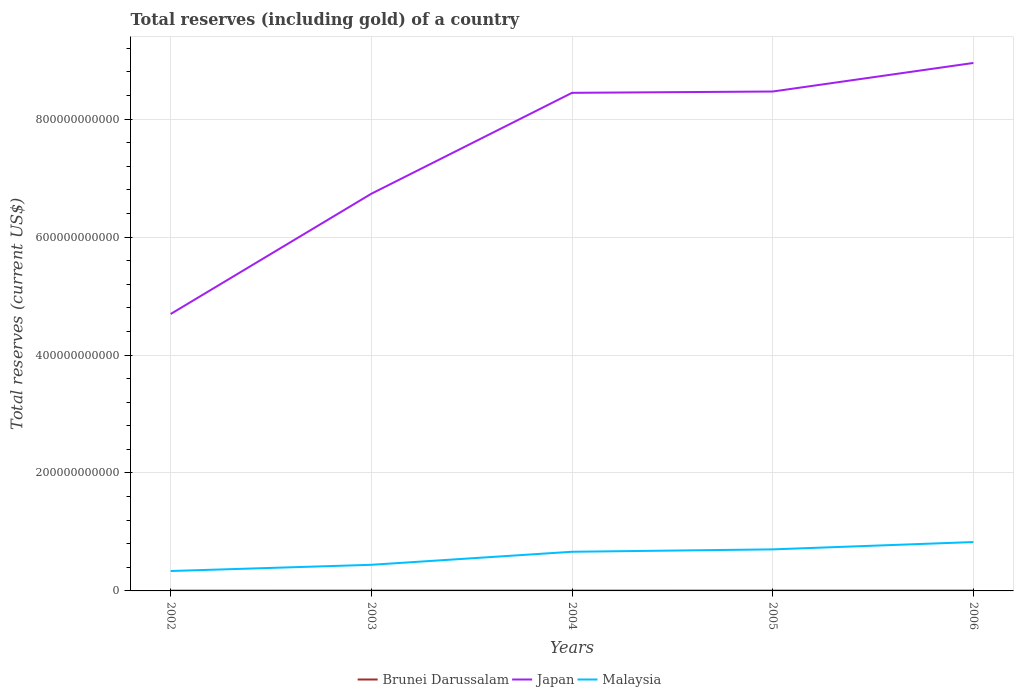Does the line corresponding to Japan intersect with the line corresponding to Brunei Darussalam?
Give a very brief answer. No. Is the number of lines equal to the number of legend labels?
Your answer should be very brief. Yes. Across all years, what is the maximum total reserves (including gold) in Brunei Darussalam?
Your answer should be compact. 4.49e+08. In which year was the total reserves (including gold) in Japan maximum?
Offer a terse response. 2002. What is the total total reserves (including gold) in Brunei Darussalam in the graph?
Provide a succinct answer. -4.29e+07. What is the difference between the highest and the second highest total reserves (including gold) in Brunei Darussalam?
Provide a succinct answer. 6.46e+07. How many years are there in the graph?
Your answer should be very brief. 5. What is the difference between two consecutive major ticks on the Y-axis?
Provide a succinct answer. 2.00e+11. Does the graph contain grids?
Your response must be concise. Yes. Where does the legend appear in the graph?
Make the answer very short. Bottom center. How many legend labels are there?
Provide a succinct answer. 3. How are the legend labels stacked?
Offer a very short reply. Horizontal. What is the title of the graph?
Your response must be concise. Total reserves (including gold) of a country. What is the label or title of the Y-axis?
Provide a short and direct response. Total reserves (current US$). What is the Total reserves (current US$) in Brunei Darussalam in 2002?
Your response must be concise. 4.49e+08. What is the Total reserves (current US$) of Japan in 2002?
Provide a short and direct response. 4.70e+11. What is the Total reserves (current US$) of Malaysia in 2002?
Provide a short and direct response. 3.38e+1. What is the Total reserves (current US$) of Brunei Darussalam in 2003?
Make the answer very short. 4.75e+08. What is the Total reserves (current US$) in Japan in 2003?
Give a very brief answer. 6.74e+11. What is the Total reserves (current US$) in Malaysia in 2003?
Provide a short and direct response. 4.43e+1. What is the Total reserves (current US$) of Brunei Darussalam in 2004?
Ensure brevity in your answer.  4.89e+08. What is the Total reserves (current US$) of Japan in 2004?
Your response must be concise. 8.45e+11. What is the Total reserves (current US$) in Malaysia in 2004?
Offer a very short reply. 6.64e+1. What is the Total reserves (current US$) of Brunei Darussalam in 2005?
Offer a terse response. 4.92e+08. What is the Total reserves (current US$) of Japan in 2005?
Provide a short and direct response. 8.47e+11. What is the Total reserves (current US$) in Malaysia in 2005?
Give a very brief answer. 7.05e+1. What is the Total reserves (current US$) of Brunei Darussalam in 2006?
Ensure brevity in your answer.  5.14e+08. What is the Total reserves (current US$) of Japan in 2006?
Provide a succinct answer. 8.95e+11. What is the Total reserves (current US$) in Malaysia in 2006?
Make the answer very short. 8.29e+1. Across all years, what is the maximum Total reserves (current US$) in Brunei Darussalam?
Offer a very short reply. 5.14e+08. Across all years, what is the maximum Total reserves (current US$) in Japan?
Keep it short and to the point. 8.95e+11. Across all years, what is the maximum Total reserves (current US$) in Malaysia?
Give a very brief answer. 8.29e+1. Across all years, what is the minimum Total reserves (current US$) in Brunei Darussalam?
Give a very brief answer. 4.49e+08. Across all years, what is the minimum Total reserves (current US$) of Japan?
Provide a succinct answer. 4.70e+11. Across all years, what is the minimum Total reserves (current US$) of Malaysia?
Keep it short and to the point. 3.38e+1. What is the total Total reserves (current US$) in Brunei Darussalam in the graph?
Your answer should be very brief. 2.42e+09. What is the total Total reserves (current US$) in Japan in the graph?
Your response must be concise. 3.73e+12. What is the total Total reserves (current US$) in Malaysia in the graph?
Offer a terse response. 2.98e+11. What is the difference between the Total reserves (current US$) in Brunei Darussalam in 2002 and that in 2003?
Your response must be concise. -2.57e+07. What is the difference between the Total reserves (current US$) in Japan in 2002 and that in 2003?
Your answer should be very brief. -2.04e+11. What is the difference between the Total reserves (current US$) of Malaysia in 2002 and that in 2003?
Keep it short and to the point. -1.05e+1. What is the difference between the Total reserves (current US$) in Brunei Darussalam in 2002 and that in 2004?
Offer a very short reply. -3.99e+07. What is the difference between the Total reserves (current US$) of Japan in 2002 and that in 2004?
Offer a very short reply. -3.75e+11. What is the difference between the Total reserves (current US$) in Malaysia in 2002 and that in 2004?
Your answer should be very brief. -3.26e+1. What is the difference between the Total reserves (current US$) of Brunei Darussalam in 2002 and that in 2005?
Give a very brief answer. -4.29e+07. What is the difference between the Total reserves (current US$) in Japan in 2002 and that in 2005?
Your answer should be compact. -3.77e+11. What is the difference between the Total reserves (current US$) of Malaysia in 2002 and that in 2005?
Offer a very short reply. -3.67e+1. What is the difference between the Total reserves (current US$) of Brunei Darussalam in 2002 and that in 2006?
Your answer should be very brief. -6.46e+07. What is the difference between the Total reserves (current US$) in Japan in 2002 and that in 2006?
Offer a very short reply. -4.26e+11. What is the difference between the Total reserves (current US$) of Malaysia in 2002 and that in 2006?
Offer a very short reply. -4.91e+1. What is the difference between the Total reserves (current US$) in Brunei Darussalam in 2003 and that in 2004?
Give a very brief answer. -1.41e+07. What is the difference between the Total reserves (current US$) in Japan in 2003 and that in 2004?
Make the answer very short. -1.71e+11. What is the difference between the Total reserves (current US$) in Malaysia in 2003 and that in 2004?
Make the answer very short. -2.21e+1. What is the difference between the Total reserves (current US$) of Brunei Darussalam in 2003 and that in 2005?
Provide a succinct answer. -1.71e+07. What is the difference between the Total reserves (current US$) of Japan in 2003 and that in 2005?
Keep it short and to the point. -1.73e+11. What is the difference between the Total reserves (current US$) in Malaysia in 2003 and that in 2005?
Offer a terse response. -2.61e+1. What is the difference between the Total reserves (current US$) of Brunei Darussalam in 2003 and that in 2006?
Your answer should be very brief. -3.88e+07. What is the difference between the Total reserves (current US$) in Japan in 2003 and that in 2006?
Keep it short and to the point. -2.22e+11. What is the difference between the Total reserves (current US$) in Malaysia in 2003 and that in 2006?
Your response must be concise. -3.86e+1. What is the difference between the Total reserves (current US$) of Brunei Darussalam in 2004 and that in 2005?
Your response must be concise. -3.00e+06. What is the difference between the Total reserves (current US$) in Japan in 2004 and that in 2005?
Provide a short and direct response. -2.23e+09. What is the difference between the Total reserves (current US$) of Malaysia in 2004 and that in 2005?
Provide a short and direct response. -4.06e+09. What is the difference between the Total reserves (current US$) in Brunei Darussalam in 2004 and that in 2006?
Provide a short and direct response. -2.47e+07. What is the difference between the Total reserves (current US$) in Japan in 2004 and that in 2006?
Provide a short and direct response. -5.07e+1. What is the difference between the Total reserves (current US$) in Malaysia in 2004 and that in 2006?
Give a very brief answer. -1.65e+1. What is the difference between the Total reserves (current US$) of Brunei Darussalam in 2005 and that in 2006?
Ensure brevity in your answer.  -2.17e+07. What is the difference between the Total reserves (current US$) in Japan in 2005 and that in 2006?
Offer a terse response. -4.84e+1. What is the difference between the Total reserves (current US$) of Malaysia in 2005 and that in 2006?
Keep it short and to the point. -1.24e+1. What is the difference between the Total reserves (current US$) of Brunei Darussalam in 2002 and the Total reserves (current US$) of Japan in 2003?
Provide a short and direct response. -6.73e+11. What is the difference between the Total reserves (current US$) in Brunei Darussalam in 2002 and the Total reserves (current US$) in Malaysia in 2003?
Provide a succinct answer. -4.39e+1. What is the difference between the Total reserves (current US$) in Japan in 2002 and the Total reserves (current US$) in Malaysia in 2003?
Keep it short and to the point. 4.25e+11. What is the difference between the Total reserves (current US$) of Brunei Darussalam in 2002 and the Total reserves (current US$) of Japan in 2004?
Provide a succinct answer. -8.44e+11. What is the difference between the Total reserves (current US$) in Brunei Darussalam in 2002 and the Total reserves (current US$) in Malaysia in 2004?
Provide a succinct answer. -6.59e+1. What is the difference between the Total reserves (current US$) of Japan in 2002 and the Total reserves (current US$) of Malaysia in 2004?
Provide a succinct answer. 4.03e+11. What is the difference between the Total reserves (current US$) in Brunei Darussalam in 2002 and the Total reserves (current US$) in Japan in 2005?
Your response must be concise. -8.46e+11. What is the difference between the Total reserves (current US$) in Brunei Darussalam in 2002 and the Total reserves (current US$) in Malaysia in 2005?
Provide a succinct answer. -7.00e+1. What is the difference between the Total reserves (current US$) of Japan in 2002 and the Total reserves (current US$) of Malaysia in 2005?
Make the answer very short. 3.99e+11. What is the difference between the Total reserves (current US$) of Brunei Darussalam in 2002 and the Total reserves (current US$) of Japan in 2006?
Provide a short and direct response. -8.95e+11. What is the difference between the Total reserves (current US$) of Brunei Darussalam in 2002 and the Total reserves (current US$) of Malaysia in 2006?
Make the answer very short. -8.24e+1. What is the difference between the Total reserves (current US$) in Japan in 2002 and the Total reserves (current US$) in Malaysia in 2006?
Offer a very short reply. 3.87e+11. What is the difference between the Total reserves (current US$) of Brunei Darussalam in 2003 and the Total reserves (current US$) of Japan in 2004?
Offer a terse response. -8.44e+11. What is the difference between the Total reserves (current US$) of Brunei Darussalam in 2003 and the Total reserves (current US$) of Malaysia in 2004?
Your response must be concise. -6.59e+1. What is the difference between the Total reserves (current US$) of Japan in 2003 and the Total reserves (current US$) of Malaysia in 2004?
Your answer should be compact. 6.07e+11. What is the difference between the Total reserves (current US$) in Brunei Darussalam in 2003 and the Total reserves (current US$) in Japan in 2005?
Provide a short and direct response. -8.46e+11. What is the difference between the Total reserves (current US$) of Brunei Darussalam in 2003 and the Total reserves (current US$) of Malaysia in 2005?
Give a very brief answer. -7.00e+1. What is the difference between the Total reserves (current US$) of Japan in 2003 and the Total reserves (current US$) of Malaysia in 2005?
Your answer should be very brief. 6.03e+11. What is the difference between the Total reserves (current US$) in Brunei Darussalam in 2003 and the Total reserves (current US$) in Japan in 2006?
Ensure brevity in your answer.  -8.95e+11. What is the difference between the Total reserves (current US$) of Brunei Darussalam in 2003 and the Total reserves (current US$) of Malaysia in 2006?
Your answer should be compact. -8.24e+1. What is the difference between the Total reserves (current US$) in Japan in 2003 and the Total reserves (current US$) in Malaysia in 2006?
Your answer should be compact. 5.91e+11. What is the difference between the Total reserves (current US$) of Brunei Darussalam in 2004 and the Total reserves (current US$) of Japan in 2005?
Provide a short and direct response. -8.46e+11. What is the difference between the Total reserves (current US$) in Brunei Darussalam in 2004 and the Total reserves (current US$) in Malaysia in 2005?
Ensure brevity in your answer.  -7.00e+1. What is the difference between the Total reserves (current US$) of Japan in 2004 and the Total reserves (current US$) of Malaysia in 2005?
Ensure brevity in your answer.  7.74e+11. What is the difference between the Total reserves (current US$) in Brunei Darussalam in 2004 and the Total reserves (current US$) in Japan in 2006?
Keep it short and to the point. -8.95e+11. What is the difference between the Total reserves (current US$) of Brunei Darussalam in 2004 and the Total reserves (current US$) of Malaysia in 2006?
Provide a succinct answer. -8.24e+1. What is the difference between the Total reserves (current US$) in Japan in 2004 and the Total reserves (current US$) in Malaysia in 2006?
Your answer should be compact. 7.62e+11. What is the difference between the Total reserves (current US$) of Brunei Darussalam in 2005 and the Total reserves (current US$) of Japan in 2006?
Ensure brevity in your answer.  -8.95e+11. What is the difference between the Total reserves (current US$) of Brunei Darussalam in 2005 and the Total reserves (current US$) of Malaysia in 2006?
Keep it short and to the point. -8.24e+1. What is the difference between the Total reserves (current US$) in Japan in 2005 and the Total reserves (current US$) in Malaysia in 2006?
Ensure brevity in your answer.  7.64e+11. What is the average Total reserves (current US$) of Brunei Darussalam per year?
Offer a very short reply. 4.84e+08. What is the average Total reserves (current US$) in Japan per year?
Provide a short and direct response. 7.46e+11. What is the average Total reserves (current US$) of Malaysia per year?
Ensure brevity in your answer.  5.96e+1. In the year 2002, what is the difference between the Total reserves (current US$) in Brunei Darussalam and Total reserves (current US$) in Japan?
Your answer should be compact. -4.69e+11. In the year 2002, what is the difference between the Total reserves (current US$) of Brunei Darussalam and Total reserves (current US$) of Malaysia?
Your answer should be compact. -3.33e+1. In the year 2002, what is the difference between the Total reserves (current US$) in Japan and Total reserves (current US$) in Malaysia?
Provide a short and direct response. 4.36e+11. In the year 2003, what is the difference between the Total reserves (current US$) of Brunei Darussalam and Total reserves (current US$) of Japan?
Keep it short and to the point. -6.73e+11. In the year 2003, what is the difference between the Total reserves (current US$) in Brunei Darussalam and Total reserves (current US$) in Malaysia?
Offer a terse response. -4.38e+1. In the year 2003, what is the difference between the Total reserves (current US$) in Japan and Total reserves (current US$) in Malaysia?
Offer a very short reply. 6.29e+11. In the year 2004, what is the difference between the Total reserves (current US$) in Brunei Darussalam and Total reserves (current US$) in Japan?
Provide a short and direct response. -8.44e+11. In the year 2004, what is the difference between the Total reserves (current US$) in Brunei Darussalam and Total reserves (current US$) in Malaysia?
Offer a terse response. -6.59e+1. In the year 2004, what is the difference between the Total reserves (current US$) in Japan and Total reserves (current US$) in Malaysia?
Your answer should be compact. 7.78e+11. In the year 2005, what is the difference between the Total reserves (current US$) in Brunei Darussalam and Total reserves (current US$) in Japan?
Keep it short and to the point. -8.46e+11. In the year 2005, what is the difference between the Total reserves (current US$) in Brunei Darussalam and Total reserves (current US$) in Malaysia?
Give a very brief answer. -7.00e+1. In the year 2005, what is the difference between the Total reserves (current US$) in Japan and Total reserves (current US$) in Malaysia?
Make the answer very short. 7.76e+11. In the year 2006, what is the difference between the Total reserves (current US$) of Brunei Darussalam and Total reserves (current US$) of Japan?
Offer a very short reply. -8.95e+11. In the year 2006, what is the difference between the Total reserves (current US$) of Brunei Darussalam and Total reserves (current US$) of Malaysia?
Provide a succinct answer. -8.24e+1. In the year 2006, what is the difference between the Total reserves (current US$) of Japan and Total reserves (current US$) of Malaysia?
Your answer should be compact. 8.12e+11. What is the ratio of the Total reserves (current US$) of Brunei Darussalam in 2002 to that in 2003?
Your response must be concise. 0.95. What is the ratio of the Total reserves (current US$) of Japan in 2002 to that in 2003?
Ensure brevity in your answer.  0.7. What is the ratio of the Total reserves (current US$) of Malaysia in 2002 to that in 2003?
Give a very brief answer. 0.76. What is the ratio of the Total reserves (current US$) of Brunei Darussalam in 2002 to that in 2004?
Provide a short and direct response. 0.92. What is the ratio of the Total reserves (current US$) in Japan in 2002 to that in 2004?
Your answer should be compact. 0.56. What is the ratio of the Total reserves (current US$) of Malaysia in 2002 to that in 2004?
Your answer should be very brief. 0.51. What is the ratio of the Total reserves (current US$) of Brunei Darussalam in 2002 to that in 2005?
Your response must be concise. 0.91. What is the ratio of the Total reserves (current US$) in Japan in 2002 to that in 2005?
Provide a short and direct response. 0.55. What is the ratio of the Total reserves (current US$) in Malaysia in 2002 to that in 2005?
Offer a very short reply. 0.48. What is the ratio of the Total reserves (current US$) of Brunei Darussalam in 2002 to that in 2006?
Give a very brief answer. 0.87. What is the ratio of the Total reserves (current US$) of Japan in 2002 to that in 2006?
Make the answer very short. 0.52. What is the ratio of the Total reserves (current US$) in Malaysia in 2002 to that in 2006?
Provide a succinct answer. 0.41. What is the ratio of the Total reserves (current US$) in Brunei Darussalam in 2003 to that in 2004?
Give a very brief answer. 0.97. What is the ratio of the Total reserves (current US$) of Japan in 2003 to that in 2004?
Give a very brief answer. 0.8. What is the ratio of the Total reserves (current US$) in Malaysia in 2003 to that in 2004?
Give a very brief answer. 0.67. What is the ratio of the Total reserves (current US$) of Brunei Darussalam in 2003 to that in 2005?
Keep it short and to the point. 0.97. What is the ratio of the Total reserves (current US$) of Japan in 2003 to that in 2005?
Your answer should be very brief. 0.8. What is the ratio of the Total reserves (current US$) of Malaysia in 2003 to that in 2005?
Give a very brief answer. 0.63. What is the ratio of the Total reserves (current US$) of Brunei Darussalam in 2003 to that in 2006?
Your answer should be very brief. 0.92. What is the ratio of the Total reserves (current US$) of Japan in 2003 to that in 2006?
Your response must be concise. 0.75. What is the ratio of the Total reserves (current US$) in Malaysia in 2003 to that in 2006?
Your response must be concise. 0.53. What is the ratio of the Total reserves (current US$) of Japan in 2004 to that in 2005?
Offer a terse response. 1. What is the ratio of the Total reserves (current US$) in Malaysia in 2004 to that in 2005?
Your response must be concise. 0.94. What is the ratio of the Total reserves (current US$) of Brunei Darussalam in 2004 to that in 2006?
Your response must be concise. 0.95. What is the ratio of the Total reserves (current US$) of Japan in 2004 to that in 2006?
Your response must be concise. 0.94. What is the ratio of the Total reserves (current US$) of Malaysia in 2004 to that in 2006?
Make the answer very short. 0.8. What is the ratio of the Total reserves (current US$) of Brunei Darussalam in 2005 to that in 2006?
Offer a terse response. 0.96. What is the ratio of the Total reserves (current US$) of Japan in 2005 to that in 2006?
Give a very brief answer. 0.95. What is the ratio of the Total reserves (current US$) of Malaysia in 2005 to that in 2006?
Provide a short and direct response. 0.85. What is the difference between the highest and the second highest Total reserves (current US$) in Brunei Darussalam?
Offer a very short reply. 2.17e+07. What is the difference between the highest and the second highest Total reserves (current US$) in Japan?
Your answer should be very brief. 4.84e+1. What is the difference between the highest and the second highest Total reserves (current US$) in Malaysia?
Offer a terse response. 1.24e+1. What is the difference between the highest and the lowest Total reserves (current US$) of Brunei Darussalam?
Your response must be concise. 6.46e+07. What is the difference between the highest and the lowest Total reserves (current US$) of Japan?
Provide a succinct answer. 4.26e+11. What is the difference between the highest and the lowest Total reserves (current US$) in Malaysia?
Provide a succinct answer. 4.91e+1. 